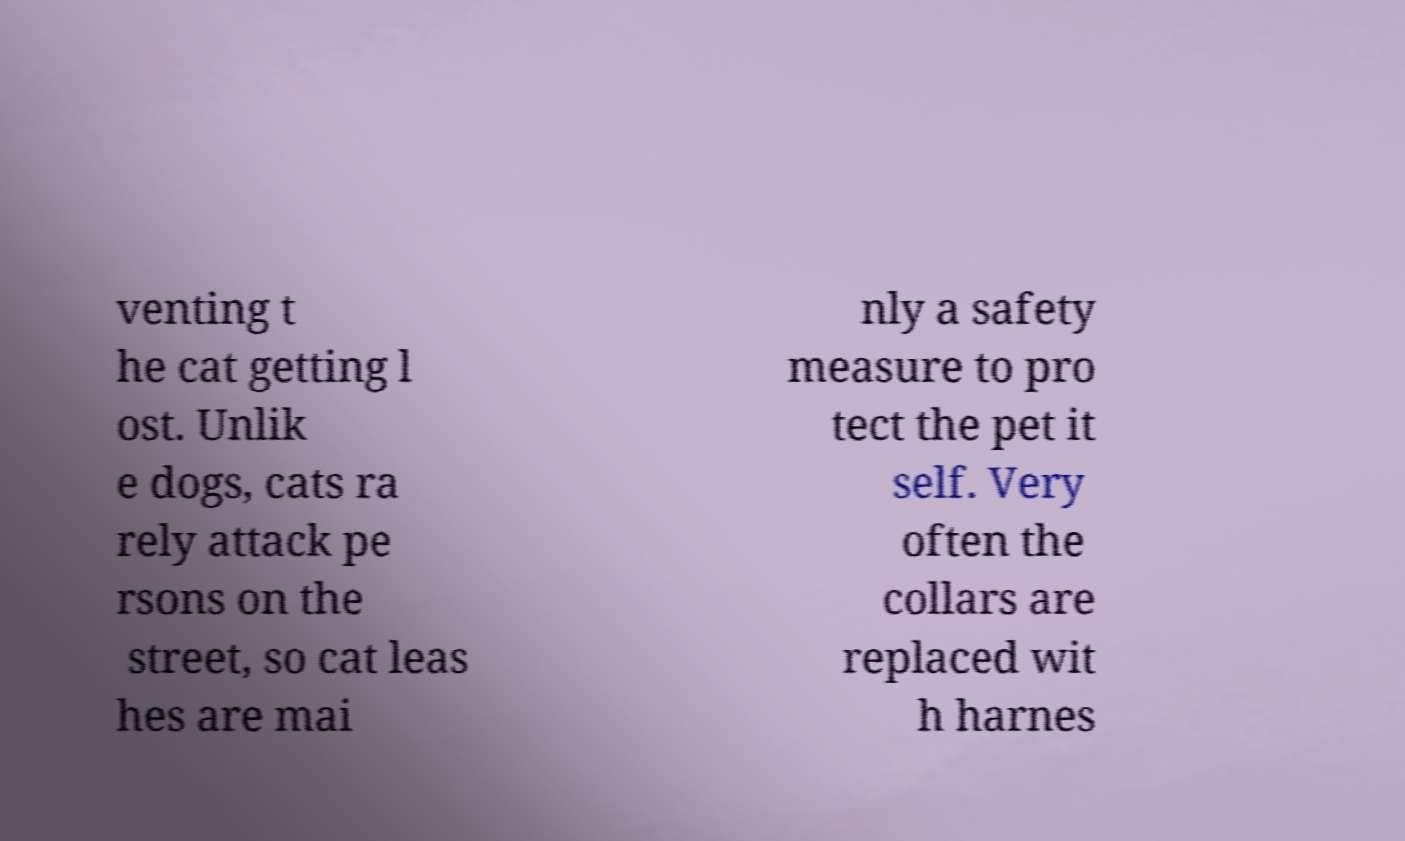Can you accurately transcribe the text from the provided image for me? venting t he cat getting l ost. Unlik e dogs, cats ra rely attack pe rsons on the street, so cat leas hes are mai nly a safety measure to pro tect the pet it self. Very often the collars are replaced wit h harnes 